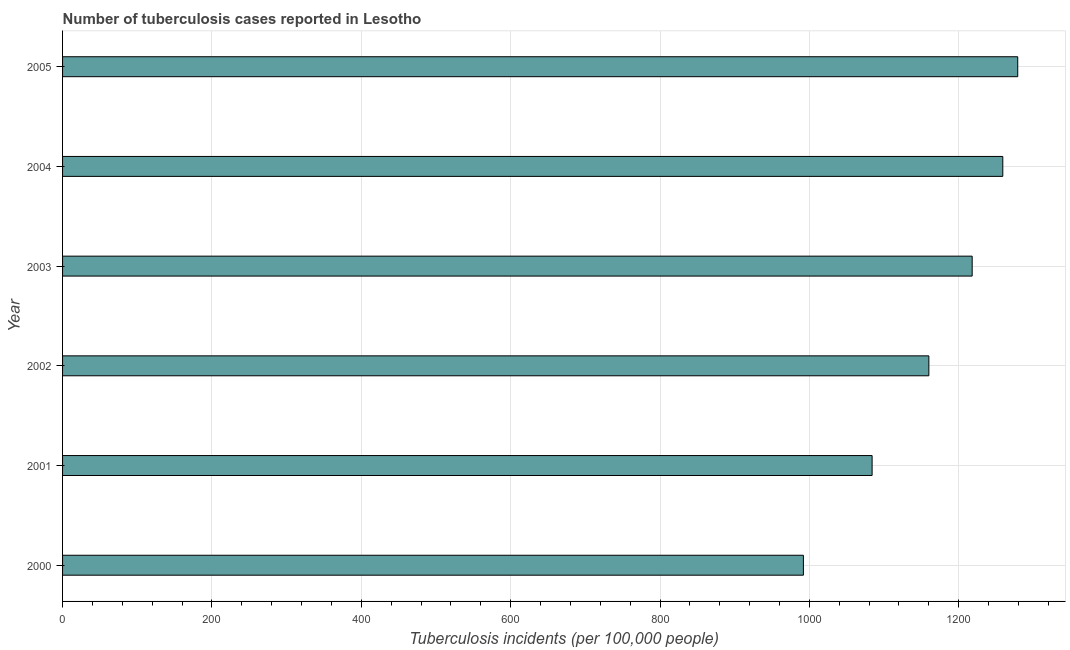What is the title of the graph?
Offer a terse response. Number of tuberculosis cases reported in Lesotho. What is the label or title of the X-axis?
Offer a terse response. Tuberculosis incidents (per 100,0 people). What is the label or title of the Y-axis?
Offer a terse response. Year. What is the number of tuberculosis incidents in 2003?
Offer a terse response. 1218. Across all years, what is the maximum number of tuberculosis incidents?
Your response must be concise. 1279. Across all years, what is the minimum number of tuberculosis incidents?
Make the answer very short. 992. In which year was the number of tuberculosis incidents minimum?
Ensure brevity in your answer.  2000. What is the sum of the number of tuberculosis incidents?
Provide a short and direct response. 6992. What is the difference between the number of tuberculosis incidents in 2004 and 2005?
Your answer should be very brief. -20. What is the average number of tuberculosis incidents per year?
Keep it short and to the point. 1165. What is the median number of tuberculosis incidents?
Offer a terse response. 1189. In how many years, is the number of tuberculosis incidents greater than 40 ?
Offer a very short reply. 6. What is the ratio of the number of tuberculosis incidents in 2004 to that in 2005?
Your response must be concise. 0.98. Is the sum of the number of tuberculosis incidents in 2000 and 2003 greater than the maximum number of tuberculosis incidents across all years?
Your response must be concise. Yes. What is the difference between the highest and the lowest number of tuberculosis incidents?
Give a very brief answer. 287. In how many years, is the number of tuberculosis incidents greater than the average number of tuberculosis incidents taken over all years?
Offer a very short reply. 3. How many bars are there?
Your answer should be very brief. 6. Are all the bars in the graph horizontal?
Provide a short and direct response. Yes. Are the values on the major ticks of X-axis written in scientific E-notation?
Your answer should be compact. No. What is the Tuberculosis incidents (per 100,000 people) of 2000?
Give a very brief answer. 992. What is the Tuberculosis incidents (per 100,000 people) of 2001?
Make the answer very short. 1084. What is the Tuberculosis incidents (per 100,000 people) in 2002?
Keep it short and to the point. 1160. What is the Tuberculosis incidents (per 100,000 people) of 2003?
Offer a very short reply. 1218. What is the Tuberculosis incidents (per 100,000 people) of 2004?
Give a very brief answer. 1259. What is the Tuberculosis incidents (per 100,000 people) of 2005?
Provide a short and direct response. 1279. What is the difference between the Tuberculosis incidents (per 100,000 people) in 2000 and 2001?
Your response must be concise. -92. What is the difference between the Tuberculosis incidents (per 100,000 people) in 2000 and 2002?
Offer a terse response. -168. What is the difference between the Tuberculosis incidents (per 100,000 people) in 2000 and 2003?
Offer a terse response. -226. What is the difference between the Tuberculosis incidents (per 100,000 people) in 2000 and 2004?
Provide a succinct answer. -267. What is the difference between the Tuberculosis incidents (per 100,000 people) in 2000 and 2005?
Give a very brief answer. -287. What is the difference between the Tuberculosis incidents (per 100,000 people) in 2001 and 2002?
Give a very brief answer. -76. What is the difference between the Tuberculosis incidents (per 100,000 people) in 2001 and 2003?
Offer a terse response. -134. What is the difference between the Tuberculosis incidents (per 100,000 people) in 2001 and 2004?
Provide a short and direct response. -175. What is the difference between the Tuberculosis incidents (per 100,000 people) in 2001 and 2005?
Give a very brief answer. -195. What is the difference between the Tuberculosis incidents (per 100,000 people) in 2002 and 2003?
Make the answer very short. -58. What is the difference between the Tuberculosis incidents (per 100,000 people) in 2002 and 2004?
Offer a terse response. -99. What is the difference between the Tuberculosis incidents (per 100,000 people) in 2002 and 2005?
Keep it short and to the point. -119. What is the difference between the Tuberculosis incidents (per 100,000 people) in 2003 and 2004?
Offer a very short reply. -41. What is the difference between the Tuberculosis incidents (per 100,000 people) in 2003 and 2005?
Make the answer very short. -61. What is the difference between the Tuberculosis incidents (per 100,000 people) in 2004 and 2005?
Your answer should be compact. -20. What is the ratio of the Tuberculosis incidents (per 100,000 people) in 2000 to that in 2001?
Ensure brevity in your answer.  0.92. What is the ratio of the Tuberculosis incidents (per 100,000 people) in 2000 to that in 2002?
Provide a succinct answer. 0.85. What is the ratio of the Tuberculosis incidents (per 100,000 people) in 2000 to that in 2003?
Your answer should be very brief. 0.81. What is the ratio of the Tuberculosis incidents (per 100,000 people) in 2000 to that in 2004?
Keep it short and to the point. 0.79. What is the ratio of the Tuberculosis incidents (per 100,000 people) in 2000 to that in 2005?
Offer a very short reply. 0.78. What is the ratio of the Tuberculosis incidents (per 100,000 people) in 2001 to that in 2002?
Ensure brevity in your answer.  0.93. What is the ratio of the Tuberculosis incidents (per 100,000 people) in 2001 to that in 2003?
Your response must be concise. 0.89. What is the ratio of the Tuberculosis incidents (per 100,000 people) in 2001 to that in 2004?
Ensure brevity in your answer.  0.86. What is the ratio of the Tuberculosis incidents (per 100,000 people) in 2001 to that in 2005?
Your answer should be very brief. 0.85. What is the ratio of the Tuberculosis incidents (per 100,000 people) in 2002 to that in 2003?
Give a very brief answer. 0.95. What is the ratio of the Tuberculosis incidents (per 100,000 people) in 2002 to that in 2004?
Make the answer very short. 0.92. What is the ratio of the Tuberculosis incidents (per 100,000 people) in 2002 to that in 2005?
Give a very brief answer. 0.91. 